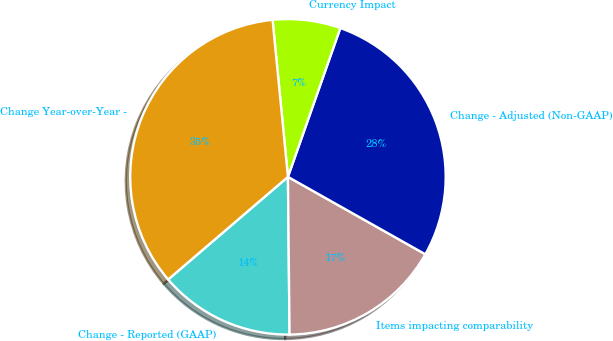Convert chart. <chart><loc_0><loc_0><loc_500><loc_500><pie_chart><fcel>Change - Reported (GAAP)<fcel>Items impacting comparability<fcel>Change - Adjusted (Non-GAAP)<fcel>Currency Impact<fcel>Change Year-over-Year -<nl><fcel>13.89%<fcel>16.67%<fcel>27.78%<fcel>6.94%<fcel>34.72%<nl></chart> 